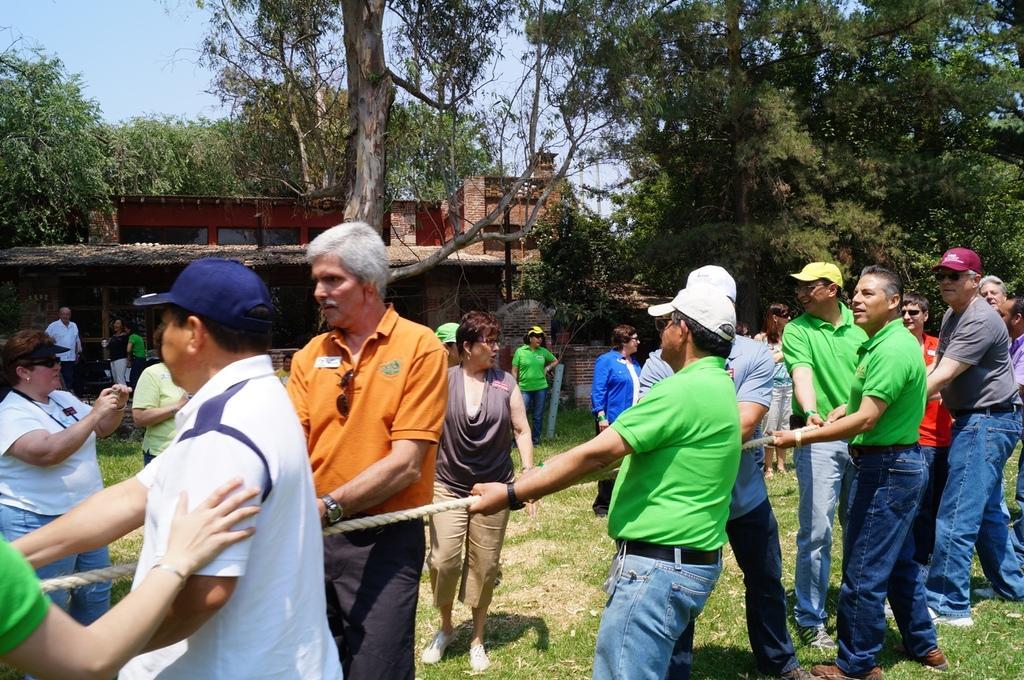In one or two sentences, can you explain what this image depicts? There are persons in different color dresses dragging white color thread on the grass on the ground. In the background, there are persons in different color dresses watching them, there are trees, a shelter, a building and there is sky. 